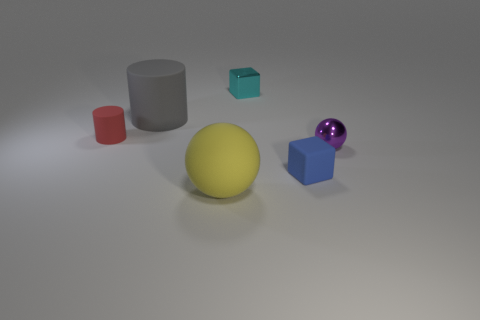What shape is the small matte thing that is on the right side of the tiny metallic thing behind the gray cylinder?
Your answer should be very brief. Cube. There is a big matte thing that is behind the yellow ball; does it have the same color as the tiny sphere?
Your answer should be very brief. No. What is the color of the matte thing that is in front of the big gray thing and behind the tiny blue matte object?
Provide a short and direct response. Red. Is there another big yellow sphere that has the same material as the yellow sphere?
Make the answer very short. No. The rubber sphere is what size?
Make the answer very short. Large. What is the size of the ball to the left of the small matte object that is in front of the shiny sphere?
Provide a short and direct response. Large. There is another thing that is the same shape as the large yellow thing; what material is it?
Your answer should be compact. Metal. What number of big gray matte cylinders are there?
Your response must be concise. 1. There is a large thing that is behind the block that is in front of the tiny matte object behind the small ball; what color is it?
Offer a terse response. Gray. Is the number of large gray cylinders less than the number of small purple metal cylinders?
Offer a terse response. No. 